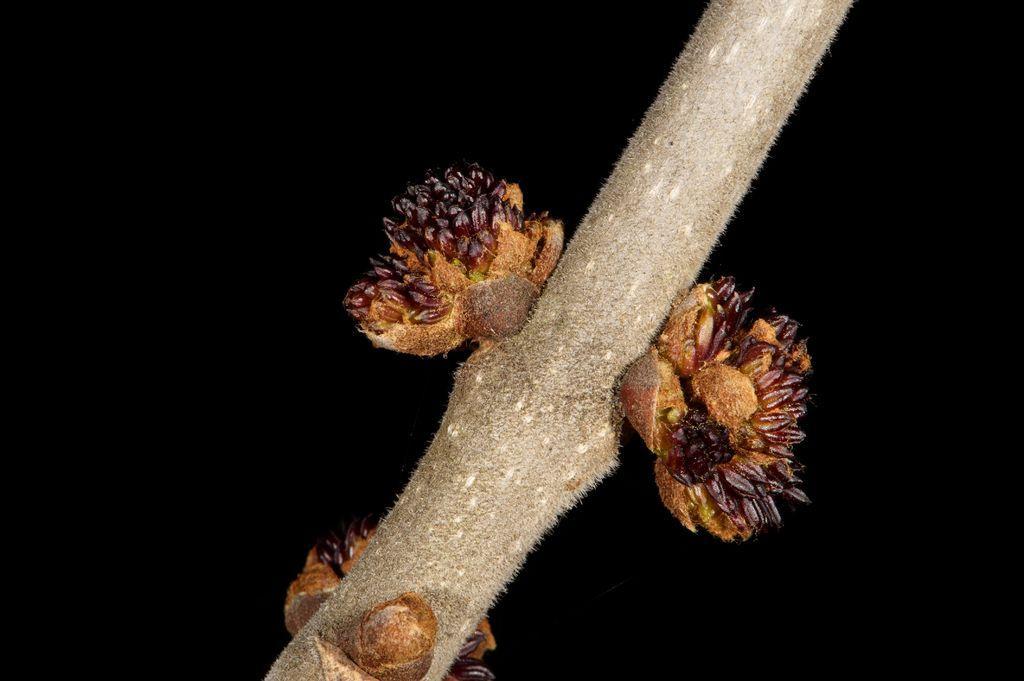In one or two sentences, can you explain what this image depicts? In this image there is a stem with stony corals, and there is dark background. 